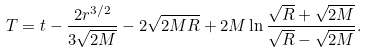Convert formula to latex. <formula><loc_0><loc_0><loc_500><loc_500>T = t - \frac { 2 r ^ { 3 / 2 } } { 3 \sqrt { 2 M } } - 2 \sqrt { 2 M R } + 2 M \ln \frac { \sqrt { R } + \sqrt { 2 M } } { \sqrt { R } - \sqrt { 2 M } } .</formula> 